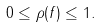<formula> <loc_0><loc_0><loc_500><loc_500>0 \leq \rho ( f ) \leq 1 .</formula> 